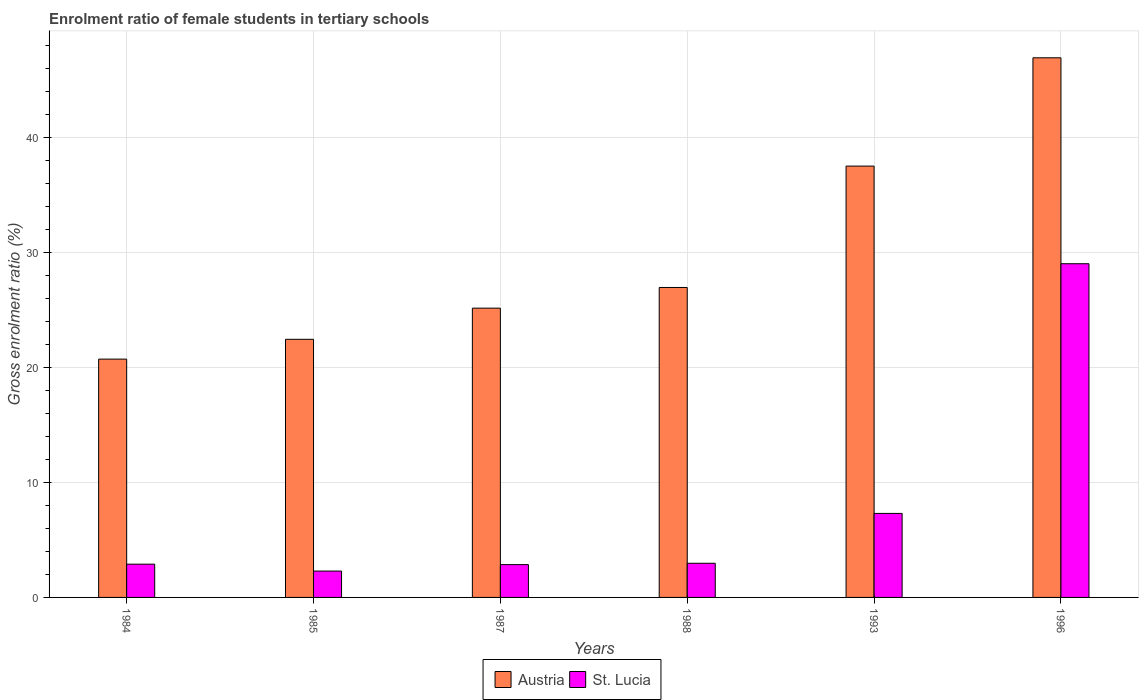How many groups of bars are there?
Provide a short and direct response. 6. Are the number of bars on each tick of the X-axis equal?
Keep it short and to the point. Yes. How many bars are there on the 1st tick from the left?
Give a very brief answer. 2. What is the label of the 2nd group of bars from the left?
Offer a terse response. 1985. What is the enrolment ratio of female students in tertiary schools in St. Lucia in 1996?
Keep it short and to the point. 29.03. Across all years, what is the maximum enrolment ratio of female students in tertiary schools in St. Lucia?
Your answer should be very brief. 29.03. Across all years, what is the minimum enrolment ratio of female students in tertiary schools in Austria?
Your answer should be compact. 20.73. In which year was the enrolment ratio of female students in tertiary schools in Austria minimum?
Provide a short and direct response. 1984. What is the total enrolment ratio of female students in tertiary schools in Austria in the graph?
Offer a very short reply. 179.8. What is the difference between the enrolment ratio of female students in tertiary schools in Austria in 1985 and that in 1996?
Offer a terse response. -24.49. What is the difference between the enrolment ratio of female students in tertiary schools in St. Lucia in 1993 and the enrolment ratio of female students in tertiary schools in Austria in 1987?
Provide a short and direct response. -17.86. What is the average enrolment ratio of female students in tertiary schools in St. Lucia per year?
Your answer should be very brief. 7.89. In the year 1984, what is the difference between the enrolment ratio of female students in tertiary schools in Austria and enrolment ratio of female students in tertiary schools in St. Lucia?
Offer a terse response. 17.84. What is the ratio of the enrolment ratio of female students in tertiary schools in St. Lucia in 1984 to that in 1987?
Your answer should be compact. 1.01. Is the enrolment ratio of female students in tertiary schools in Austria in 1985 less than that in 1988?
Make the answer very short. Yes. Is the difference between the enrolment ratio of female students in tertiary schools in Austria in 1984 and 1985 greater than the difference between the enrolment ratio of female students in tertiary schools in St. Lucia in 1984 and 1985?
Your response must be concise. No. What is the difference between the highest and the second highest enrolment ratio of female students in tertiary schools in St. Lucia?
Offer a terse response. 21.72. What is the difference between the highest and the lowest enrolment ratio of female students in tertiary schools in St. Lucia?
Ensure brevity in your answer.  26.74. Is the sum of the enrolment ratio of female students in tertiary schools in Austria in 1984 and 1993 greater than the maximum enrolment ratio of female students in tertiary schools in St. Lucia across all years?
Keep it short and to the point. Yes. What does the 2nd bar from the left in 1996 represents?
Make the answer very short. St. Lucia. What does the 2nd bar from the right in 1987 represents?
Your answer should be compact. Austria. How many bars are there?
Your answer should be compact. 12. Are all the bars in the graph horizontal?
Provide a short and direct response. No. What is the difference between two consecutive major ticks on the Y-axis?
Give a very brief answer. 10. Does the graph contain any zero values?
Give a very brief answer. No. Does the graph contain grids?
Your answer should be compact. Yes. Where does the legend appear in the graph?
Give a very brief answer. Bottom center. How many legend labels are there?
Your response must be concise. 2. How are the legend labels stacked?
Provide a short and direct response. Horizontal. What is the title of the graph?
Ensure brevity in your answer.  Enrolment ratio of female students in tertiary schools. What is the Gross enrolment ratio (%) of Austria in 1984?
Provide a succinct answer. 20.73. What is the Gross enrolment ratio (%) of St. Lucia in 1984?
Offer a terse response. 2.89. What is the Gross enrolment ratio (%) in Austria in 1985?
Offer a terse response. 22.46. What is the Gross enrolment ratio (%) of St. Lucia in 1985?
Provide a succinct answer. 2.29. What is the Gross enrolment ratio (%) of Austria in 1987?
Offer a very short reply. 25.17. What is the Gross enrolment ratio (%) in St. Lucia in 1987?
Keep it short and to the point. 2.86. What is the Gross enrolment ratio (%) of Austria in 1988?
Your response must be concise. 26.97. What is the Gross enrolment ratio (%) in St. Lucia in 1988?
Your answer should be compact. 2.97. What is the Gross enrolment ratio (%) in Austria in 1993?
Give a very brief answer. 37.53. What is the Gross enrolment ratio (%) of St. Lucia in 1993?
Provide a short and direct response. 7.31. What is the Gross enrolment ratio (%) in Austria in 1996?
Provide a short and direct response. 46.95. What is the Gross enrolment ratio (%) of St. Lucia in 1996?
Your answer should be very brief. 29.03. Across all years, what is the maximum Gross enrolment ratio (%) of Austria?
Provide a succinct answer. 46.95. Across all years, what is the maximum Gross enrolment ratio (%) in St. Lucia?
Offer a very short reply. 29.03. Across all years, what is the minimum Gross enrolment ratio (%) of Austria?
Give a very brief answer. 20.73. Across all years, what is the minimum Gross enrolment ratio (%) of St. Lucia?
Your response must be concise. 2.29. What is the total Gross enrolment ratio (%) in Austria in the graph?
Ensure brevity in your answer.  179.8. What is the total Gross enrolment ratio (%) of St. Lucia in the graph?
Make the answer very short. 47.36. What is the difference between the Gross enrolment ratio (%) of Austria in 1984 and that in 1985?
Ensure brevity in your answer.  -1.72. What is the difference between the Gross enrolment ratio (%) of St. Lucia in 1984 and that in 1985?
Offer a terse response. 0.6. What is the difference between the Gross enrolment ratio (%) in Austria in 1984 and that in 1987?
Offer a very short reply. -4.44. What is the difference between the Gross enrolment ratio (%) of St. Lucia in 1984 and that in 1987?
Your answer should be compact. 0.04. What is the difference between the Gross enrolment ratio (%) in Austria in 1984 and that in 1988?
Give a very brief answer. -6.23. What is the difference between the Gross enrolment ratio (%) in St. Lucia in 1984 and that in 1988?
Your response must be concise. -0.08. What is the difference between the Gross enrolment ratio (%) in Austria in 1984 and that in 1993?
Keep it short and to the point. -16.79. What is the difference between the Gross enrolment ratio (%) of St. Lucia in 1984 and that in 1993?
Give a very brief answer. -4.42. What is the difference between the Gross enrolment ratio (%) in Austria in 1984 and that in 1996?
Your answer should be very brief. -26.22. What is the difference between the Gross enrolment ratio (%) of St. Lucia in 1984 and that in 1996?
Make the answer very short. -26.14. What is the difference between the Gross enrolment ratio (%) of Austria in 1985 and that in 1987?
Provide a succinct answer. -2.71. What is the difference between the Gross enrolment ratio (%) of St. Lucia in 1985 and that in 1987?
Ensure brevity in your answer.  -0.56. What is the difference between the Gross enrolment ratio (%) of Austria in 1985 and that in 1988?
Your answer should be very brief. -4.51. What is the difference between the Gross enrolment ratio (%) of St. Lucia in 1985 and that in 1988?
Give a very brief answer. -0.68. What is the difference between the Gross enrolment ratio (%) in Austria in 1985 and that in 1993?
Provide a short and direct response. -15.07. What is the difference between the Gross enrolment ratio (%) of St. Lucia in 1985 and that in 1993?
Provide a short and direct response. -5.02. What is the difference between the Gross enrolment ratio (%) of Austria in 1985 and that in 1996?
Provide a succinct answer. -24.49. What is the difference between the Gross enrolment ratio (%) of St. Lucia in 1985 and that in 1996?
Provide a short and direct response. -26.74. What is the difference between the Gross enrolment ratio (%) in Austria in 1987 and that in 1988?
Your answer should be compact. -1.8. What is the difference between the Gross enrolment ratio (%) in St. Lucia in 1987 and that in 1988?
Your answer should be compact. -0.12. What is the difference between the Gross enrolment ratio (%) of Austria in 1987 and that in 1993?
Offer a terse response. -12.36. What is the difference between the Gross enrolment ratio (%) in St. Lucia in 1987 and that in 1993?
Keep it short and to the point. -4.45. What is the difference between the Gross enrolment ratio (%) in Austria in 1987 and that in 1996?
Make the answer very short. -21.78. What is the difference between the Gross enrolment ratio (%) in St. Lucia in 1987 and that in 1996?
Your response must be concise. -26.18. What is the difference between the Gross enrolment ratio (%) of Austria in 1988 and that in 1993?
Offer a very short reply. -10.56. What is the difference between the Gross enrolment ratio (%) in St. Lucia in 1988 and that in 1993?
Your answer should be very brief. -4.34. What is the difference between the Gross enrolment ratio (%) of Austria in 1988 and that in 1996?
Your response must be concise. -19.98. What is the difference between the Gross enrolment ratio (%) in St. Lucia in 1988 and that in 1996?
Keep it short and to the point. -26.06. What is the difference between the Gross enrolment ratio (%) in Austria in 1993 and that in 1996?
Provide a short and direct response. -9.42. What is the difference between the Gross enrolment ratio (%) of St. Lucia in 1993 and that in 1996?
Ensure brevity in your answer.  -21.72. What is the difference between the Gross enrolment ratio (%) of Austria in 1984 and the Gross enrolment ratio (%) of St. Lucia in 1985?
Ensure brevity in your answer.  18.44. What is the difference between the Gross enrolment ratio (%) in Austria in 1984 and the Gross enrolment ratio (%) in St. Lucia in 1987?
Provide a succinct answer. 17.88. What is the difference between the Gross enrolment ratio (%) in Austria in 1984 and the Gross enrolment ratio (%) in St. Lucia in 1988?
Your answer should be compact. 17.76. What is the difference between the Gross enrolment ratio (%) in Austria in 1984 and the Gross enrolment ratio (%) in St. Lucia in 1993?
Offer a very short reply. 13.42. What is the difference between the Gross enrolment ratio (%) of Austria in 1984 and the Gross enrolment ratio (%) of St. Lucia in 1996?
Provide a short and direct response. -8.3. What is the difference between the Gross enrolment ratio (%) in Austria in 1985 and the Gross enrolment ratio (%) in St. Lucia in 1987?
Your answer should be compact. 19.6. What is the difference between the Gross enrolment ratio (%) of Austria in 1985 and the Gross enrolment ratio (%) of St. Lucia in 1988?
Offer a very short reply. 19.49. What is the difference between the Gross enrolment ratio (%) of Austria in 1985 and the Gross enrolment ratio (%) of St. Lucia in 1993?
Your response must be concise. 15.15. What is the difference between the Gross enrolment ratio (%) of Austria in 1985 and the Gross enrolment ratio (%) of St. Lucia in 1996?
Offer a very short reply. -6.58. What is the difference between the Gross enrolment ratio (%) in Austria in 1987 and the Gross enrolment ratio (%) in St. Lucia in 1988?
Make the answer very short. 22.2. What is the difference between the Gross enrolment ratio (%) in Austria in 1987 and the Gross enrolment ratio (%) in St. Lucia in 1993?
Offer a terse response. 17.86. What is the difference between the Gross enrolment ratio (%) in Austria in 1987 and the Gross enrolment ratio (%) in St. Lucia in 1996?
Give a very brief answer. -3.87. What is the difference between the Gross enrolment ratio (%) of Austria in 1988 and the Gross enrolment ratio (%) of St. Lucia in 1993?
Give a very brief answer. 19.66. What is the difference between the Gross enrolment ratio (%) in Austria in 1988 and the Gross enrolment ratio (%) in St. Lucia in 1996?
Give a very brief answer. -2.07. What is the difference between the Gross enrolment ratio (%) in Austria in 1993 and the Gross enrolment ratio (%) in St. Lucia in 1996?
Your response must be concise. 8.49. What is the average Gross enrolment ratio (%) in Austria per year?
Ensure brevity in your answer.  29.97. What is the average Gross enrolment ratio (%) in St. Lucia per year?
Your answer should be very brief. 7.89. In the year 1984, what is the difference between the Gross enrolment ratio (%) of Austria and Gross enrolment ratio (%) of St. Lucia?
Provide a short and direct response. 17.84. In the year 1985, what is the difference between the Gross enrolment ratio (%) of Austria and Gross enrolment ratio (%) of St. Lucia?
Provide a succinct answer. 20.16. In the year 1987, what is the difference between the Gross enrolment ratio (%) of Austria and Gross enrolment ratio (%) of St. Lucia?
Your answer should be compact. 22.31. In the year 1988, what is the difference between the Gross enrolment ratio (%) in Austria and Gross enrolment ratio (%) in St. Lucia?
Your answer should be very brief. 24. In the year 1993, what is the difference between the Gross enrolment ratio (%) of Austria and Gross enrolment ratio (%) of St. Lucia?
Your answer should be very brief. 30.22. In the year 1996, what is the difference between the Gross enrolment ratio (%) in Austria and Gross enrolment ratio (%) in St. Lucia?
Give a very brief answer. 17.92. What is the ratio of the Gross enrolment ratio (%) of Austria in 1984 to that in 1985?
Ensure brevity in your answer.  0.92. What is the ratio of the Gross enrolment ratio (%) in St. Lucia in 1984 to that in 1985?
Provide a short and direct response. 1.26. What is the ratio of the Gross enrolment ratio (%) of Austria in 1984 to that in 1987?
Offer a terse response. 0.82. What is the ratio of the Gross enrolment ratio (%) in St. Lucia in 1984 to that in 1987?
Keep it short and to the point. 1.01. What is the ratio of the Gross enrolment ratio (%) in Austria in 1984 to that in 1988?
Your response must be concise. 0.77. What is the ratio of the Gross enrolment ratio (%) of St. Lucia in 1984 to that in 1988?
Your answer should be very brief. 0.97. What is the ratio of the Gross enrolment ratio (%) in Austria in 1984 to that in 1993?
Keep it short and to the point. 0.55. What is the ratio of the Gross enrolment ratio (%) in St. Lucia in 1984 to that in 1993?
Keep it short and to the point. 0.4. What is the ratio of the Gross enrolment ratio (%) in Austria in 1984 to that in 1996?
Your answer should be very brief. 0.44. What is the ratio of the Gross enrolment ratio (%) of St. Lucia in 1984 to that in 1996?
Provide a succinct answer. 0.1. What is the ratio of the Gross enrolment ratio (%) of Austria in 1985 to that in 1987?
Your answer should be compact. 0.89. What is the ratio of the Gross enrolment ratio (%) in St. Lucia in 1985 to that in 1987?
Make the answer very short. 0.8. What is the ratio of the Gross enrolment ratio (%) of Austria in 1985 to that in 1988?
Give a very brief answer. 0.83. What is the ratio of the Gross enrolment ratio (%) of St. Lucia in 1985 to that in 1988?
Your answer should be very brief. 0.77. What is the ratio of the Gross enrolment ratio (%) of Austria in 1985 to that in 1993?
Make the answer very short. 0.6. What is the ratio of the Gross enrolment ratio (%) in St. Lucia in 1985 to that in 1993?
Ensure brevity in your answer.  0.31. What is the ratio of the Gross enrolment ratio (%) in Austria in 1985 to that in 1996?
Make the answer very short. 0.48. What is the ratio of the Gross enrolment ratio (%) in St. Lucia in 1985 to that in 1996?
Offer a terse response. 0.08. What is the ratio of the Gross enrolment ratio (%) of Austria in 1987 to that in 1988?
Offer a terse response. 0.93. What is the ratio of the Gross enrolment ratio (%) of St. Lucia in 1987 to that in 1988?
Make the answer very short. 0.96. What is the ratio of the Gross enrolment ratio (%) in Austria in 1987 to that in 1993?
Your answer should be very brief. 0.67. What is the ratio of the Gross enrolment ratio (%) of St. Lucia in 1987 to that in 1993?
Ensure brevity in your answer.  0.39. What is the ratio of the Gross enrolment ratio (%) in Austria in 1987 to that in 1996?
Make the answer very short. 0.54. What is the ratio of the Gross enrolment ratio (%) in St. Lucia in 1987 to that in 1996?
Make the answer very short. 0.1. What is the ratio of the Gross enrolment ratio (%) of Austria in 1988 to that in 1993?
Your response must be concise. 0.72. What is the ratio of the Gross enrolment ratio (%) of St. Lucia in 1988 to that in 1993?
Provide a succinct answer. 0.41. What is the ratio of the Gross enrolment ratio (%) of Austria in 1988 to that in 1996?
Your response must be concise. 0.57. What is the ratio of the Gross enrolment ratio (%) in St. Lucia in 1988 to that in 1996?
Ensure brevity in your answer.  0.1. What is the ratio of the Gross enrolment ratio (%) of Austria in 1993 to that in 1996?
Provide a short and direct response. 0.8. What is the ratio of the Gross enrolment ratio (%) in St. Lucia in 1993 to that in 1996?
Offer a terse response. 0.25. What is the difference between the highest and the second highest Gross enrolment ratio (%) of Austria?
Provide a succinct answer. 9.42. What is the difference between the highest and the second highest Gross enrolment ratio (%) in St. Lucia?
Provide a short and direct response. 21.72. What is the difference between the highest and the lowest Gross enrolment ratio (%) of Austria?
Provide a succinct answer. 26.22. What is the difference between the highest and the lowest Gross enrolment ratio (%) in St. Lucia?
Keep it short and to the point. 26.74. 